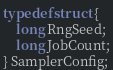<code> <loc_0><loc_0><loc_500><loc_500><_C_>typedef struct {
	long RngSeed;
	long JobCount;
} SamplerConfig;</code> 